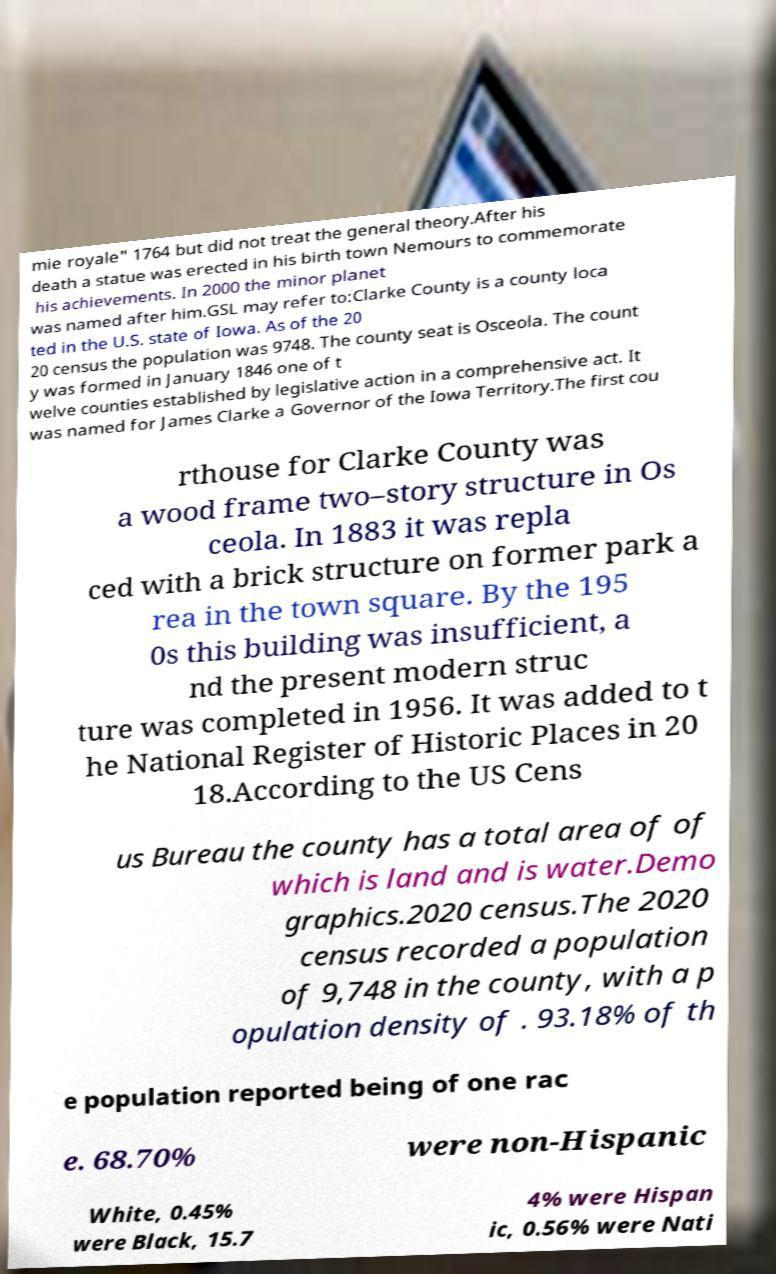I need the written content from this picture converted into text. Can you do that? mie royale" 1764 but did not treat the general theory.After his death a statue was erected in his birth town Nemours to commemorate his achievements. In 2000 the minor planet was named after him.GSL may refer to:Clarke County is a county loca ted in the U.S. state of Iowa. As of the 20 20 census the population was 9748. The county seat is Osceola. The count y was formed in January 1846 one of t welve counties established by legislative action in a comprehensive act. It was named for James Clarke a Governor of the Iowa Territory.The first cou rthouse for Clarke County was a wood frame two–story structure in Os ceola. In 1883 it was repla ced with a brick structure on former park a rea in the town square. By the 195 0s this building was insufficient, a nd the present modern struc ture was completed in 1956. It was added to t he National Register of Historic Places in 20 18.According to the US Cens us Bureau the county has a total area of of which is land and is water.Demo graphics.2020 census.The 2020 census recorded a population of 9,748 in the county, with a p opulation density of . 93.18% of th e population reported being of one rac e. 68.70% were non-Hispanic White, 0.45% were Black, 15.7 4% were Hispan ic, 0.56% were Nati 